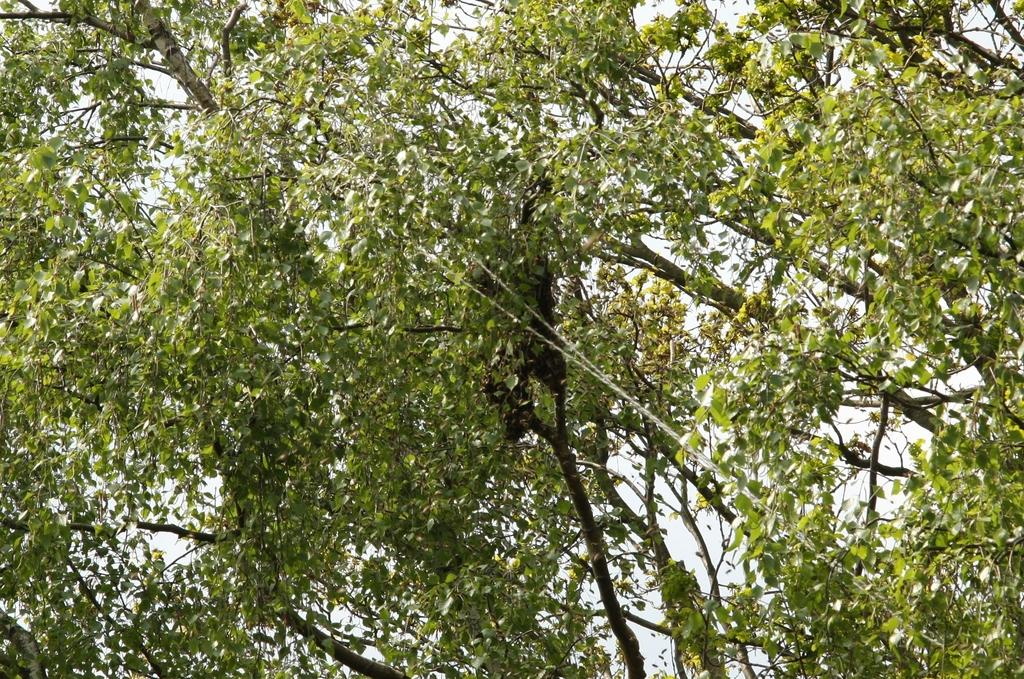What is present in the image? There is a tree in the image. What can be observed about the tree's appearance? The tree has green leaves. What type of waste is visible in the image? There is no waste present in the image; it only features a tree with green leaves. 